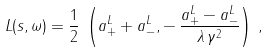<formula> <loc_0><loc_0><loc_500><loc_500>L ( s , \omega ) = \frac { 1 } { 2 } \, \left ( a _ { + } ^ { L } + a _ { - } ^ { L } , - \, \frac { a _ { + } ^ { L } - a _ { - } ^ { L } } { \lambda \, \gamma ^ { 2 } } \right ) \, ,</formula> 